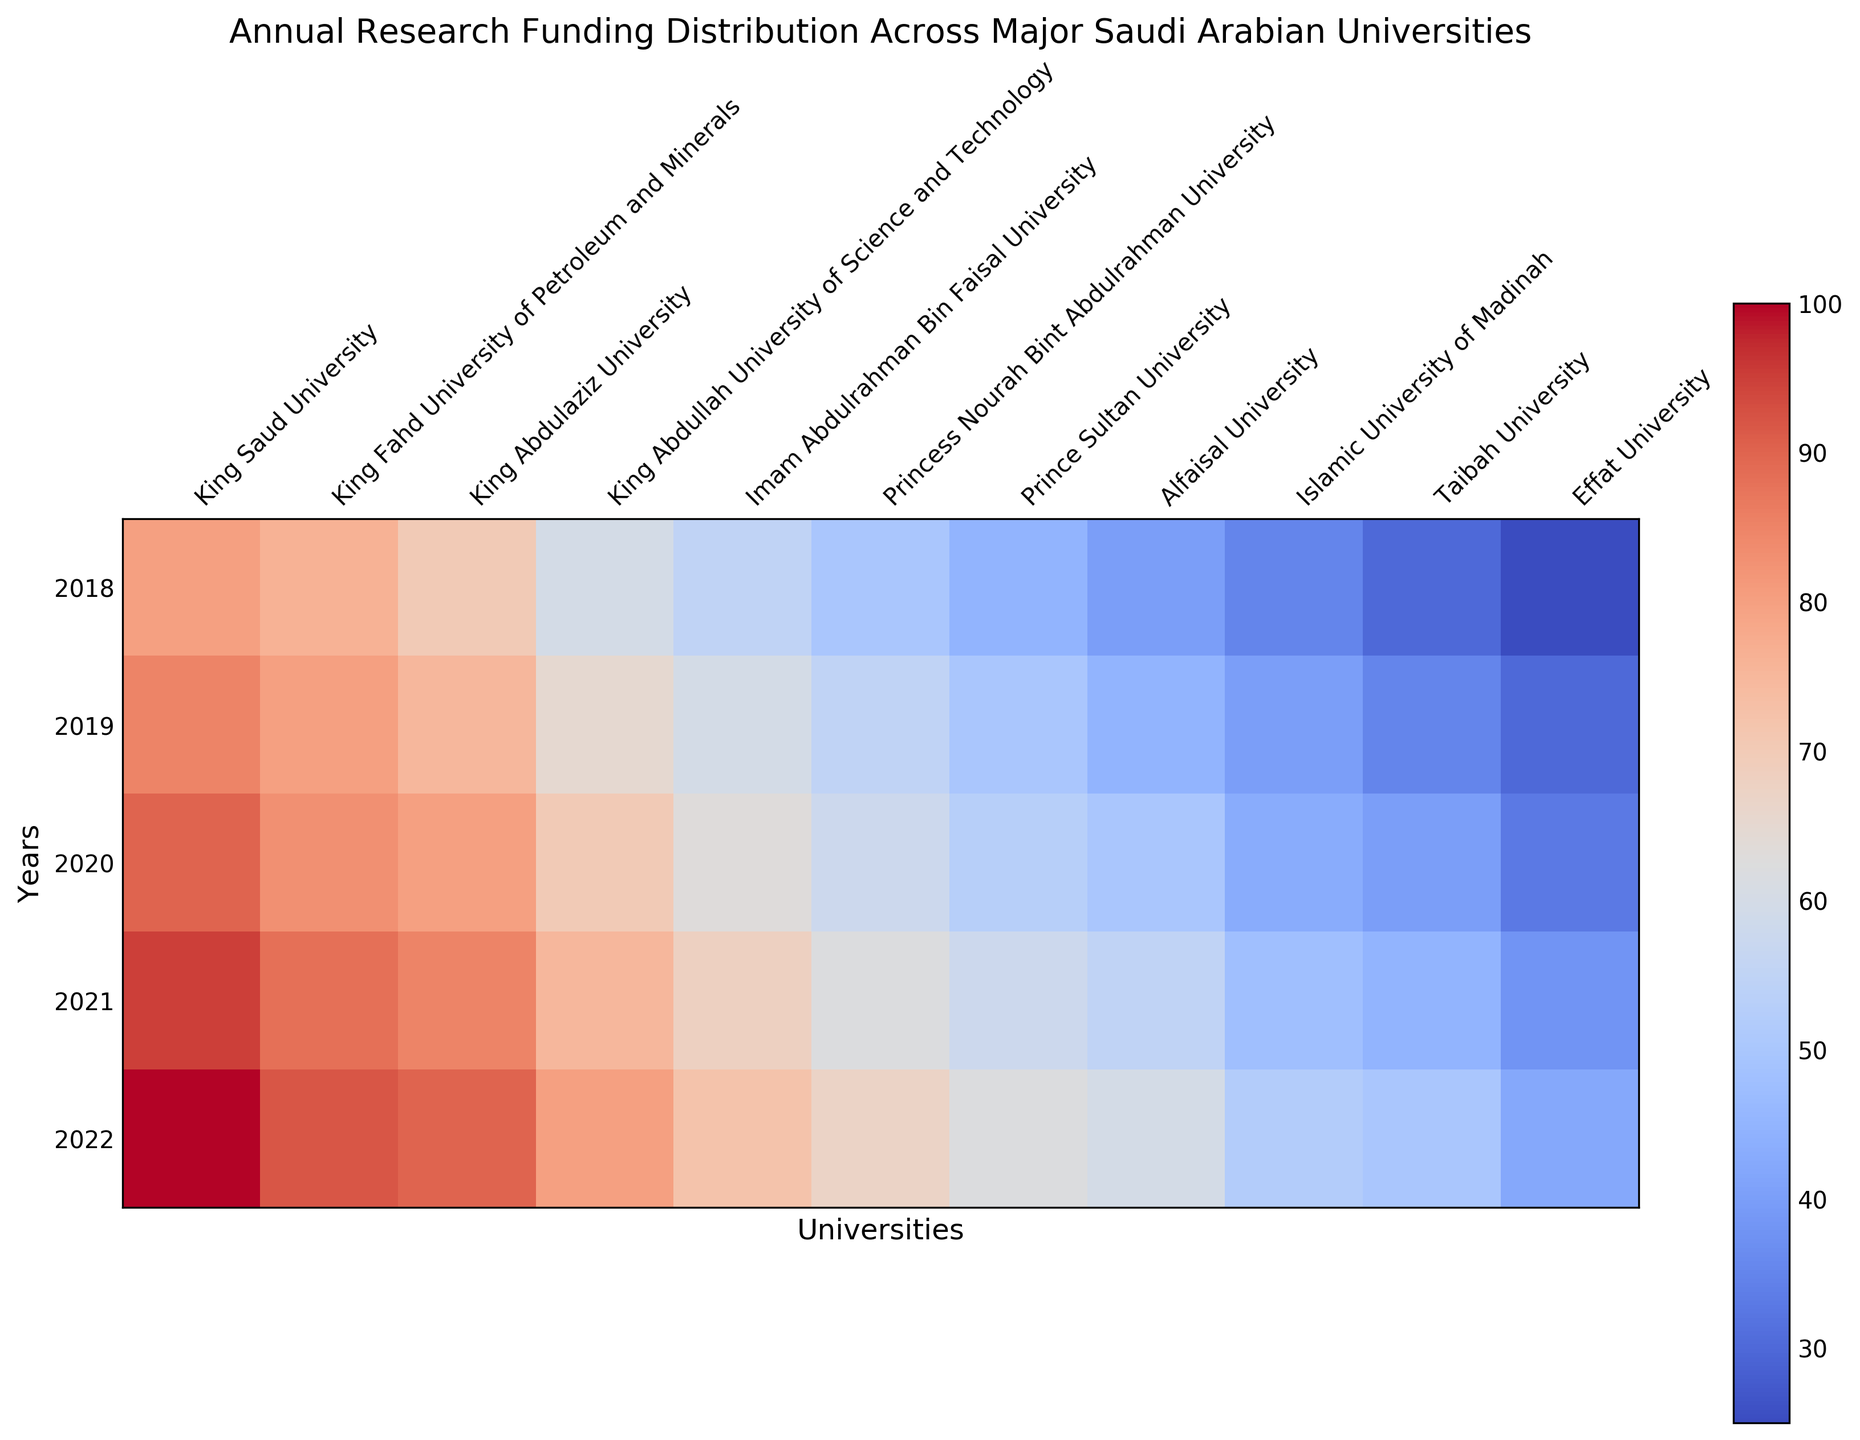What is the highest annual research funding amount in 2022? To find the highest funding amount in 2022, look at the column for 2022 and identify the maximum value. The highest value is from King Saud University, which has a funding amount of 100.
Answer: 100 How does the funding amount for King Abdulaziz University in 2020 compare with that in 2021? Compare the values for King Abdulaziz University in the years 2020 and 2021. The values are 80 in 2020 and 85 in 2021, showing an increase.
Answer: Increase Which university had the lowest research funding in 2018? Look at the 2018 column and find the university with the lowest value. The lowest value is 25 for Effat University.
Answer: Effat University What is the average research funding for King Fahd University of Petroleum and Minerals over the five years? Add the funding amounts for the King Fahd University of Petroleum and Minerals from 2018 to 2022 and divide by 5: (76 + 80 + 83 + 88 + 92) / 5 = 419 / 5 = 83.8
Answer: 83.8 Between 2019 and 2022, which university showed the most growth in research funding? Calculate the funding difference between 2019 and 2022 for each university and identify the university with the highest growth. The differences are King Saud University: 15, King Fahd University of Petroleum and Minerals: 12, King Abdulaziz University: 15, King Abdullah University of Science and Technology: 15, Imam Abdulrahman Bin Faisal University: 12, Princess Nourah Bint Abdulrahman University: 12, Prince Sultan University: 12, Alfaisal University: 15, Islamic University of Madinah: 12, Taibah University: 15, Effat University: 12. Therefore, King Saud University, King Abdulaziz University, King Abdullah University of Science and Technology, Alfaisal University, and Taibah University have the same highest growth of 15 units.
Answer: King Saud University, King Abdulaziz University, King Abdullah University of Science and Technology, Alfaisal University, Taibah University Which university's funding increased consistently every year from 2018 to 2022? Identify universities with increasing values from 2018 to 2022 for all years. King Saud University, King Fahd University of Petroleum and Minerals, King Abdulaziz University, King Abdullah University of Science and Technology, Imam Abdulrahman Bin Faisal University, Princess Nourah Bint Abdulrahman University, Prince Sultan University, Alfaisal University, Islamic University of Madinah, and Effat University all show consistent increases.
Answer: King Saud University, King Fahd University of Petroleum and Minerals, King Abdulaziz University, King Abdullah University of Science and Technology, Imam Abdulrahman Bin Faisal University, Princess Nourah Bint Abdulrahman University, Prince Sultan University, Alfaisal University, Islamic University of Madinah, Effat University What is the difference in research funding for Islamic University of Madinah between 2022 and 2018? Subtract the funding amount for 2018 from that for 2022 for Islamic University of Madinah. The values are 52 in 2022 and 35 in 2018. The difference is 52 - 35 = 17.
Answer: 17 Which universities had funding of at least 90 in any year? Look across all columns for universities with any value of 90 or above. King Saud University and King Abdulaziz University both meet this criterion.
Answer: King Saud University, King Abdulaziz University 